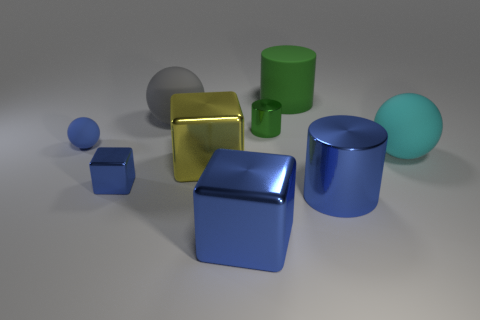What is the color of the small matte thing?
Keep it short and to the point. Blue. What number of other things are there of the same size as the cyan object?
Offer a very short reply. 5. There is a big blue thing that is the same shape as the large yellow shiny thing; what material is it?
Offer a very short reply. Metal. What is the blue block that is in front of the blue metal object to the left of the large blue thing in front of the large blue metal cylinder made of?
Ensure brevity in your answer.  Metal. The yellow thing that is made of the same material as the small blue block is what size?
Make the answer very short. Large. Are there any other things of the same color as the tiny block?
Provide a short and direct response. Yes. There is a small metallic object on the left side of the tiny shiny cylinder; is its color the same as the large matte ball that is behind the small green shiny thing?
Offer a very short reply. No. There is a large cylinder that is right of the large matte cylinder; what is its color?
Keep it short and to the point. Blue. Does the yellow cube on the left side of the green metal cylinder have the same size as the large cyan matte ball?
Your answer should be very brief. Yes. Is the number of large matte objects less than the number of small green metal objects?
Keep it short and to the point. No. 